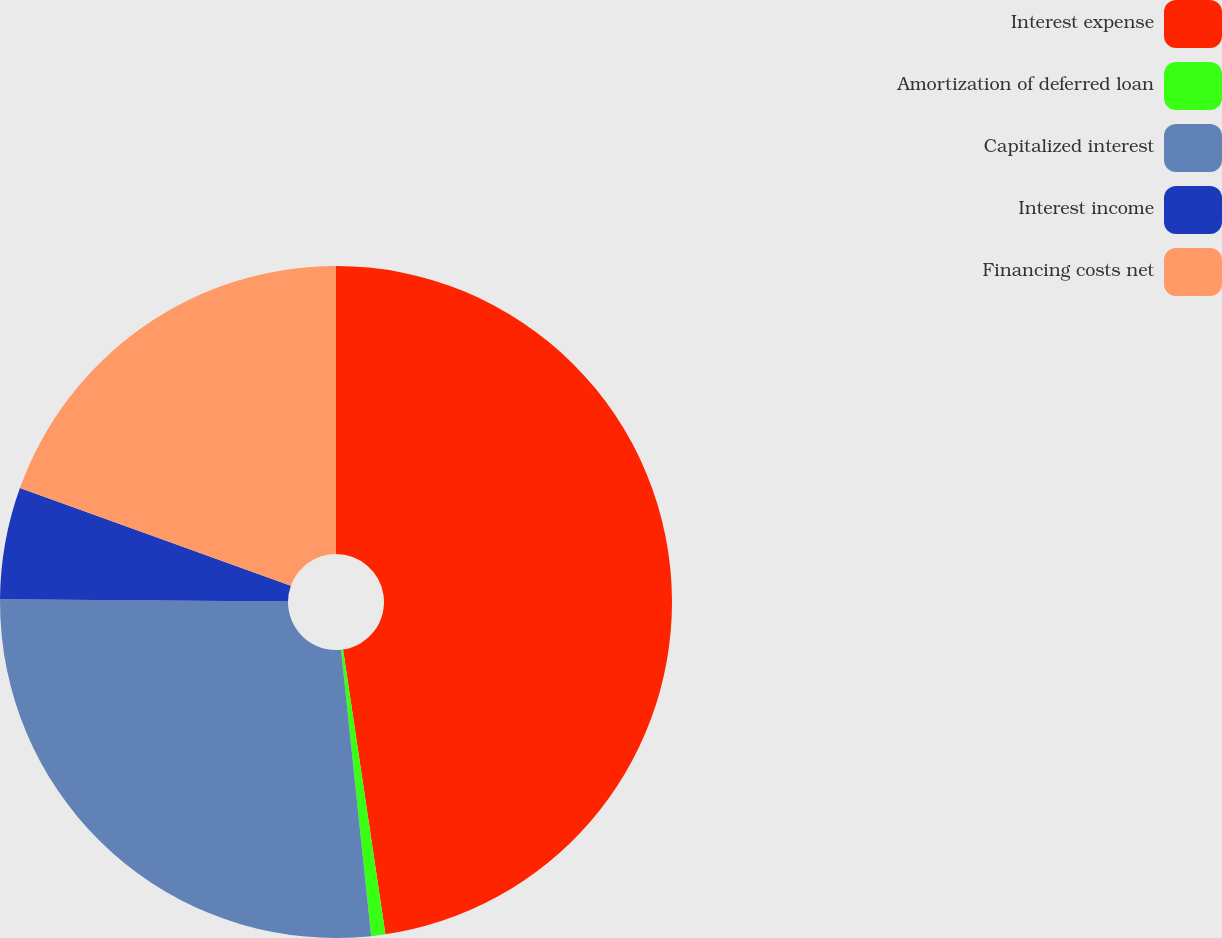Convert chart to OTSL. <chart><loc_0><loc_0><loc_500><loc_500><pie_chart><fcel>Interest expense<fcel>Amortization of deferred loan<fcel>Capitalized interest<fcel>Interest income<fcel>Financing costs net<nl><fcel>47.65%<fcel>0.68%<fcel>26.8%<fcel>5.38%<fcel>19.49%<nl></chart> 